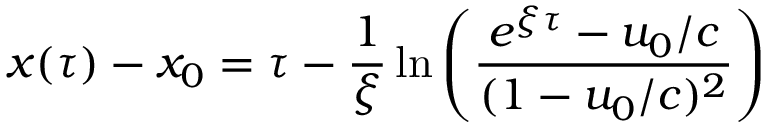<formula> <loc_0><loc_0><loc_500><loc_500>x ( \tau ) - x _ { 0 } = \tau - \frac { 1 } { \xi } \ln \left ( \frac { e ^ { \xi \tau } - u _ { 0 } / c } { ( 1 - u _ { 0 } / c ) ^ { 2 } } \right )</formula> 